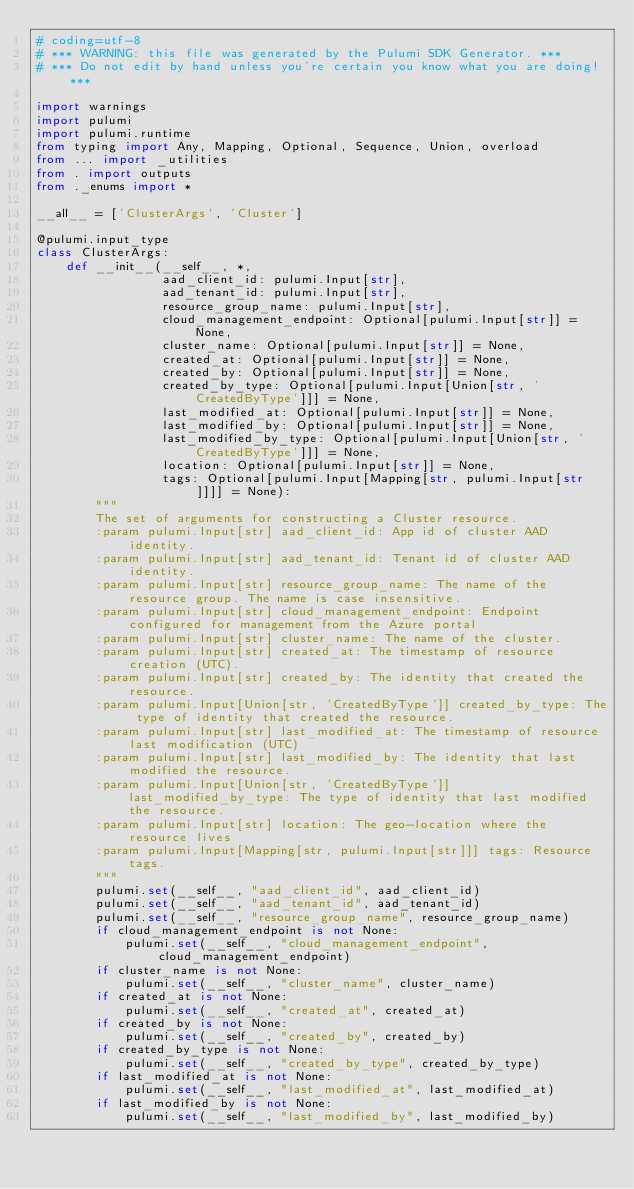Convert code to text. <code><loc_0><loc_0><loc_500><loc_500><_Python_># coding=utf-8
# *** WARNING: this file was generated by the Pulumi SDK Generator. ***
# *** Do not edit by hand unless you're certain you know what you are doing! ***

import warnings
import pulumi
import pulumi.runtime
from typing import Any, Mapping, Optional, Sequence, Union, overload
from ... import _utilities
from . import outputs
from ._enums import *

__all__ = ['ClusterArgs', 'Cluster']

@pulumi.input_type
class ClusterArgs:
    def __init__(__self__, *,
                 aad_client_id: pulumi.Input[str],
                 aad_tenant_id: pulumi.Input[str],
                 resource_group_name: pulumi.Input[str],
                 cloud_management_endpoint: Optional[pulumi.Input[str]] = None,
                 cluster_name: Optional[pulumi.Input[str]] = None,
                 created_at: Optional[pulumi.Input[str]] = None,
                 created_by: Optional[pulumi.Input[str]] = None,
                 created_by_type: Optional[pulumi.Input[Union[str, 'CreatedByType']]] = None,
                 last_modified_at: Optional[pulumi.Input[str]] = None,
                 last_modified_by: Optional[pulumi.Input[str]] = None,
                 last_modified_by_type: Optional[pulumi.Input[Union[str, 'CreatedByType']]] = None,
                 location: Optional[pulumi.Input[str]] = None,
                 tags: Optional[pulumi.Input[Mapping[str, pulumi.Input[str]]]] = None):
        """
        The set of arguments for constructing a Cluster resource.
        :param pulumi.Input[str] aad_client_id: App id of cluster AAD identity.
        :param pulumi.Input[str] aad_tenant_id: Tenant id of cluster AAD identity.
        :param pulumi.Input[str] resource_group_name: The name of the resource group. The name is case insensitive.
        :param pulumi.Input[str] cloud_management_endpoint: Endpoint configured for management from the Azure portal
        :param pulumi.Input[str] cluster_name: The name of the cluster.
        :param pulumi.Input[str] created_at: The timestamp of resource creation (UTC).
        :param pulumi.Input[str] created_by: The identity that created the resource.
        :param pulumi.Input[Union[str, 'CreatedByType']] created_by_type: The type of identity that created the resource.
        :param pulumi.Input[str] last_modified_at: The timestamp of resource last modification (UTC)
        :param pulumi.Input[str] last_modified_by: The identity that last modified the resource.
        :param pulumi.Input[Union[str, 'CreatedByType']] last_modified_by_type: The type of identity that last modified the resource.
        :param pulumi.Input[str] location: The geo-location where the resource lives
        :param pulumi.Input[Mapping[str, pulumi.Input[str]]] tags: Resource tags.
        """
        pulumi.set(__self__, "aad_client_id", aad_client_id)
        pulumi.set(__self__, "aad_tenant_id", aad_tenant_id)
        pulumi.set(__self__, "resource_group_name", resource_group_name)
        if cloud_management_endpoint is not None:
            pulumi.set(__self__, "cloud_management_endpoint", cloud_management_endpoint)
        if cluster_name is not None:
            pulumi.set(__self__, "cluster_name", cluster_name)
        if created_at is not None:
            pulumi.set(__self__, "created_at", created_at)
        if created_by is not None:
            pulumi.set(__self__, "created_by", created_by)
        if created_by_type is not None:
            pulumi.set(__self__, "created_by_type", created_by_type)
        if last_modified_at is not None:
            pulumi.set(__self__, "last_modified_at", last_modified_at)
        if last_modified_by is not None:
            pulumi.set(__self__, "last_modified_by", last_modified_by)</code> 